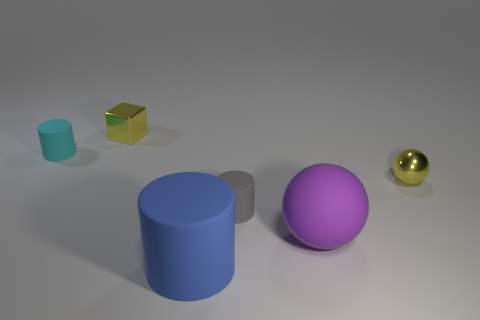Add 3 big cyan cylinders. How many objects exist? 9 Subtract all spheres. How many objects are left? 4 Add 2 purple shiny cylinders. How many purple shiny cylinders exist? 2 Subtract 1 purple balls. How many objects are left? 5 Subtract all gray cylinders. Subtract all small yellow metal balls. How many objects are left? 4 Add 5 purple rubber balls. How many purple rubber balls are left? 6 